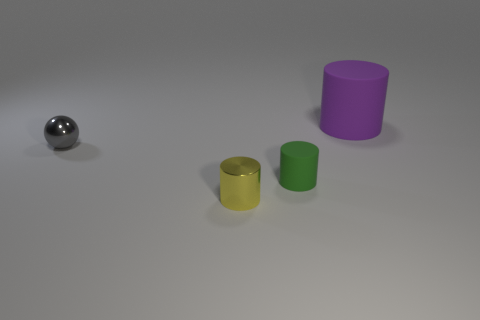Add 2 large green metallic cubes. How many objects exist? 6 Subtract all balls. How many objects are left? 3 Add 4 blue rubber blocks. How many blue rubber blocks exist? 4 Subtract 0 blue balls. How many objects are left? 4 Subtract all large gray rubber objects. Subtract all metal balls. How many objects are left? 3 Add 3 small green matte objects. How many small green matte objects are left? 4 